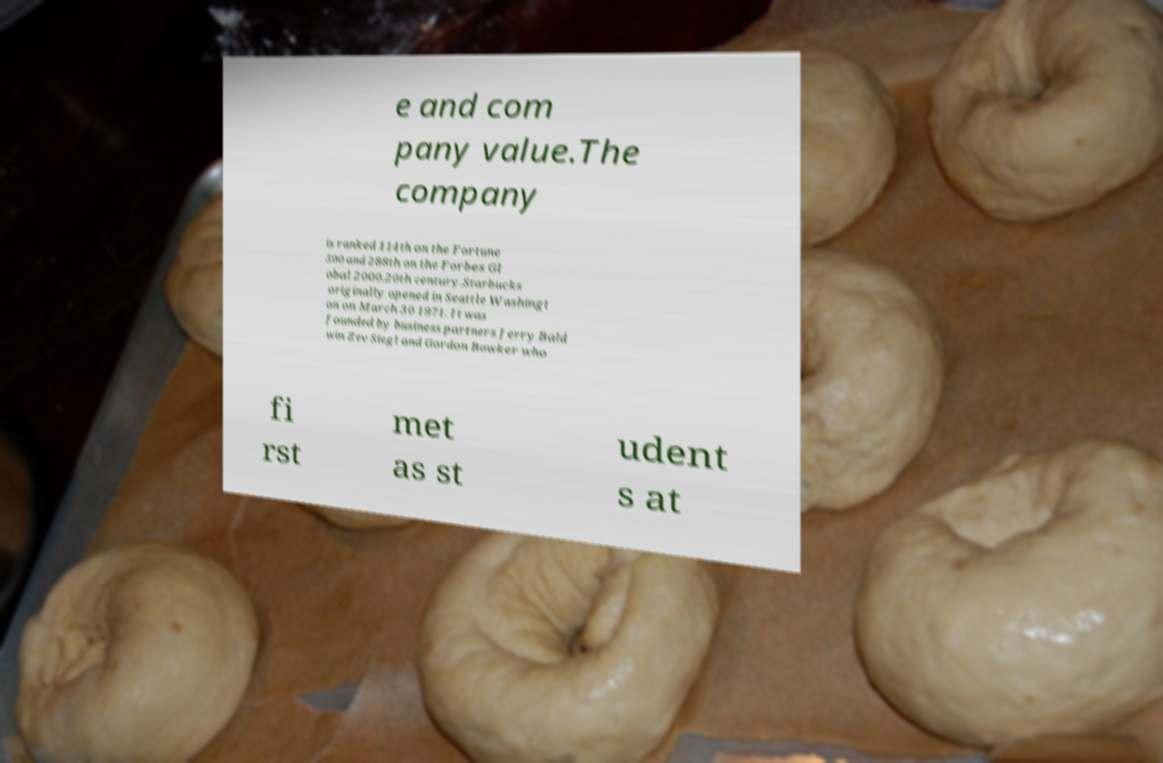I need the written content from this picture converted into text. Can you do that? e and com pany value.The company is ranked 114th on the Fortune 500 and 288th on the Forbes Gl obal 2000.20th century.Starbucks originally opened in Seattle Washingt on on March 30 1971. It was founded by business partners Jerry Bald win Zev Siegl and Gordon Bowker who fi rst met as st udent s at 